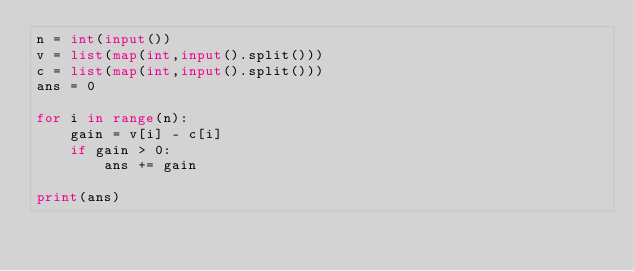<code> <loc_0><loc_0><loc_500><loc_500><_Python_>n = int(input())
v = list(map(int,input().split()))
c = list(map(int,input().split()))
ans = 0

for i in range(n):
    gain = v[i] - c[i]
    if gain > 0:
        ans += gain

print(ans)</code> 